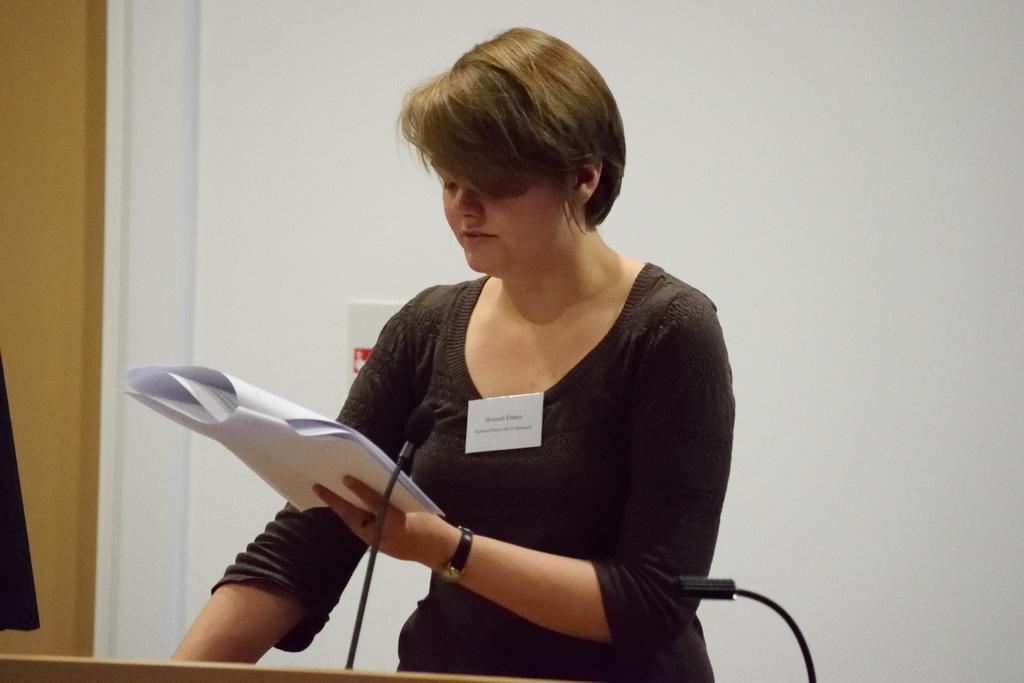Please provide a concise description of this image. In this picture there is a lady in the center of the image, by holding papers in her hand and there is a mic and desk in front of her, it seems to be there is a curtain on the left side of the image and there is another mic at the bottom side of the image. 